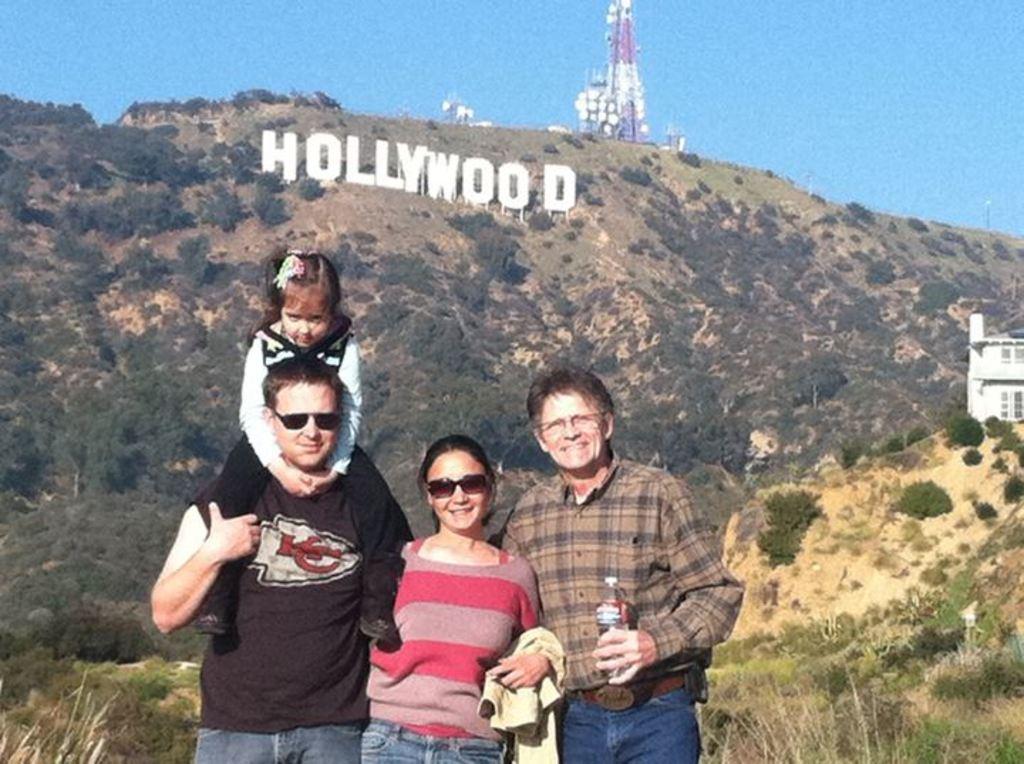How would you summarize this image in a sentence or two? In this picture I can see a girl sitting on the man. I can see a woman and a jacket on her hand. I can see a person holding a bottle in his hand. Some grass is visible at the back. I can see some plants on the right side. I can see some plants and a text on the hills. A tower is visible in the background. Sky is blue in color. 